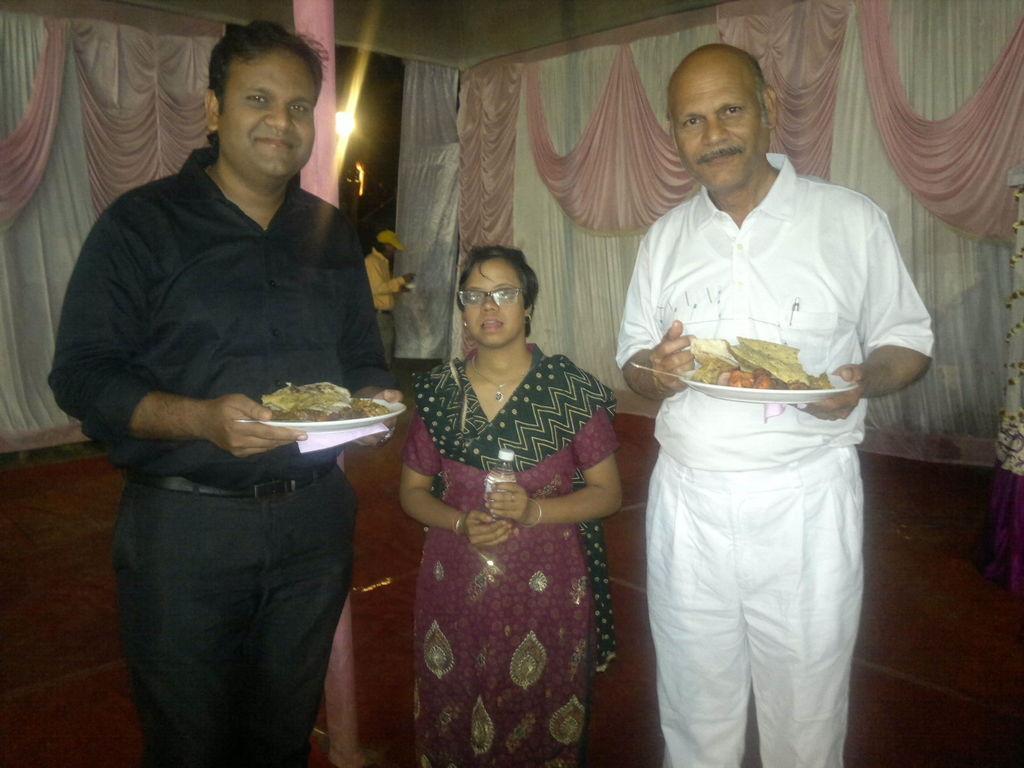Describe this image in one or two sentences. In this picture we can see persons,two persons are holding plates with food items,one woman is holding a bottle and in the background we can see curtains,light. 